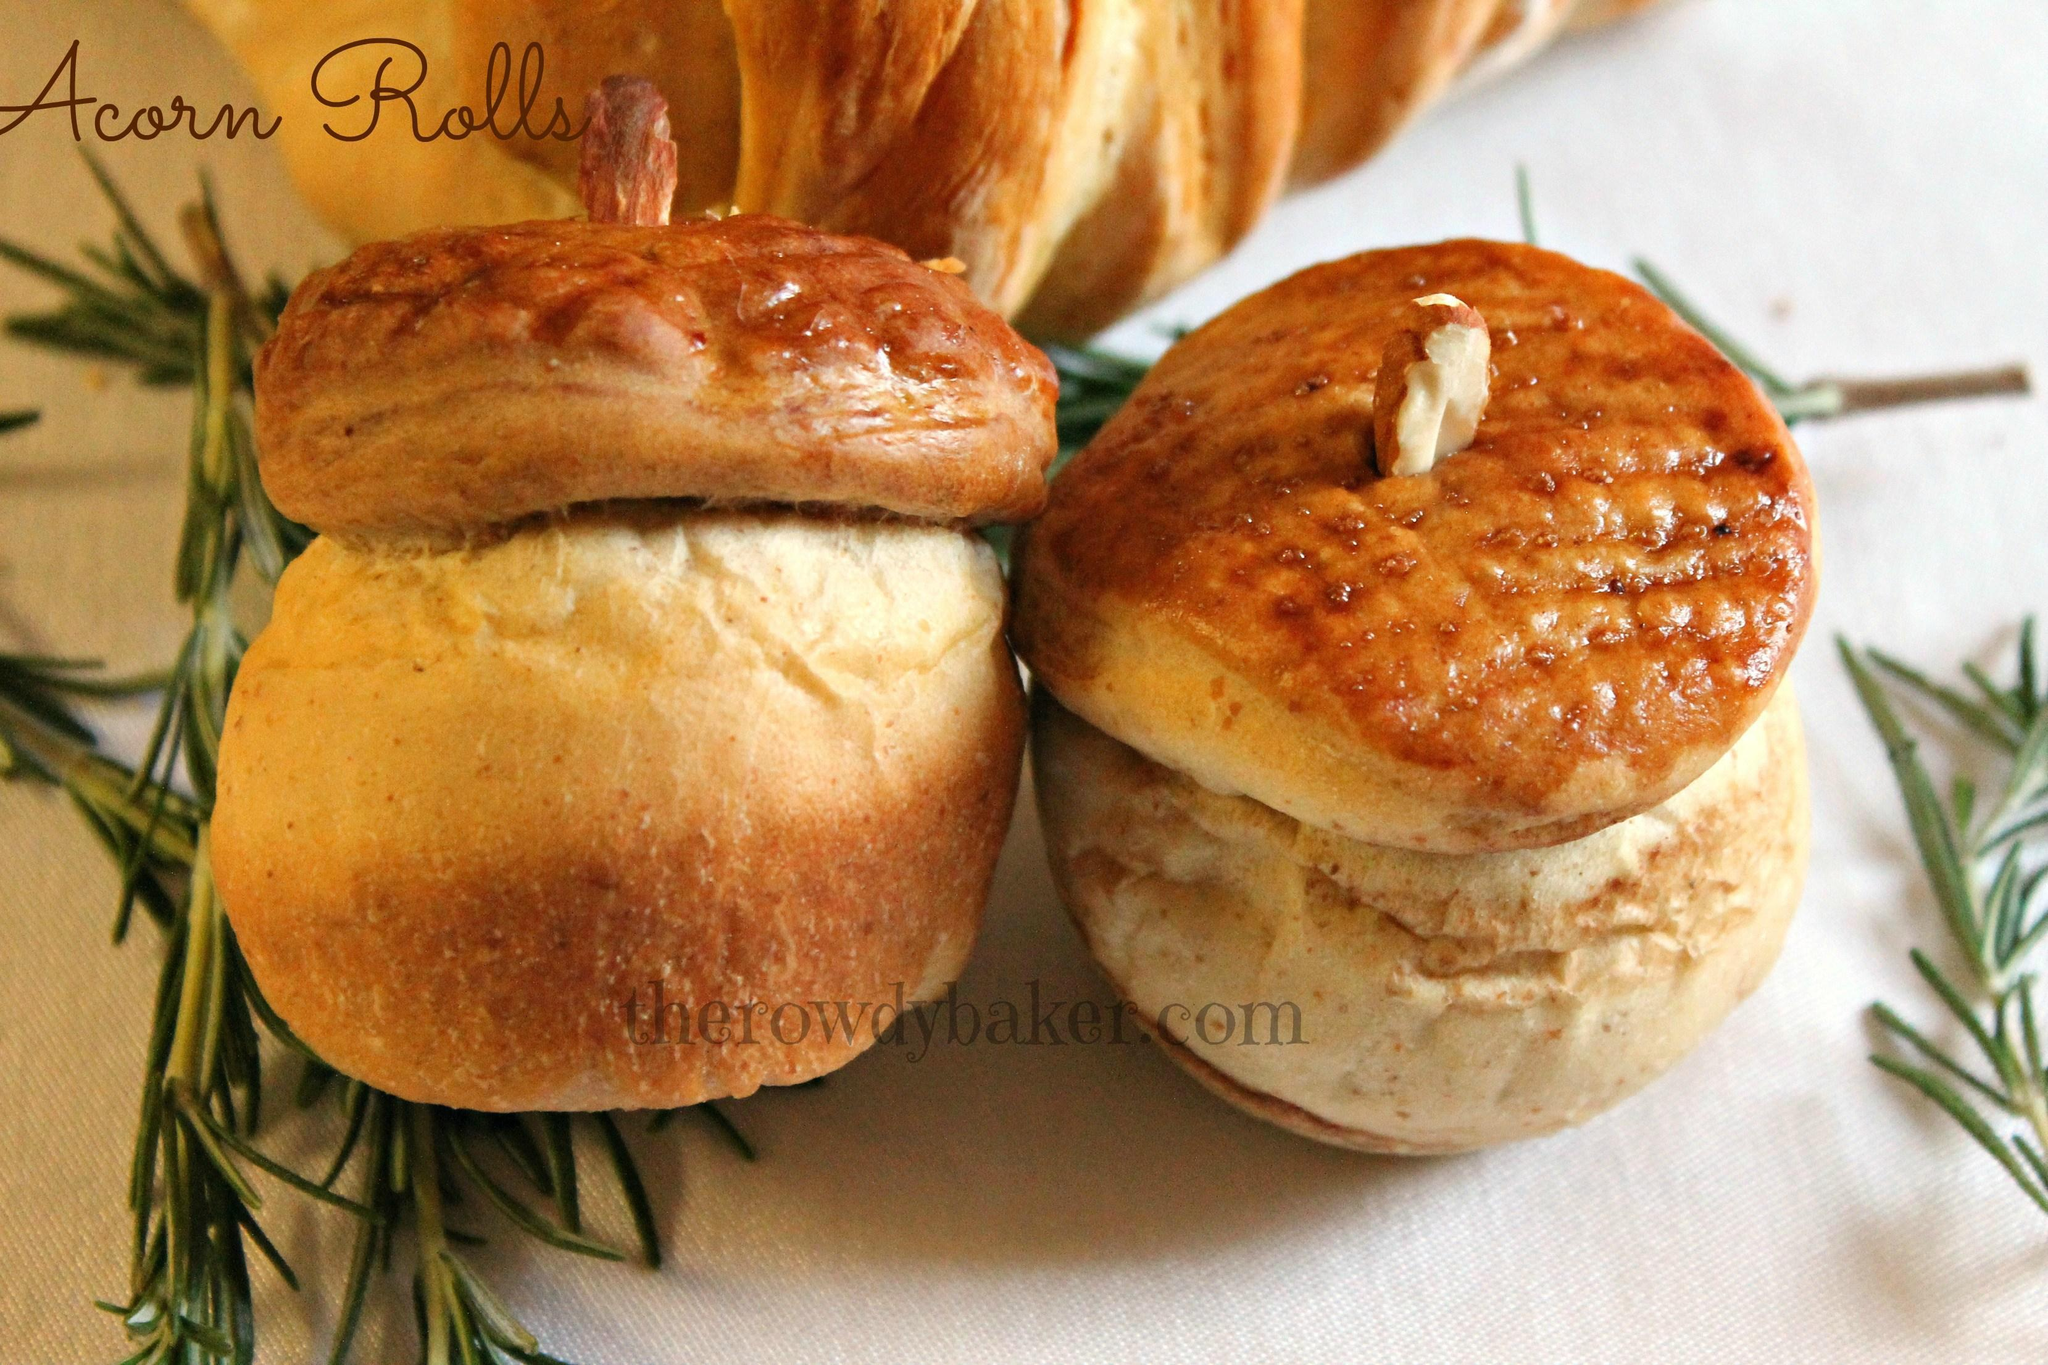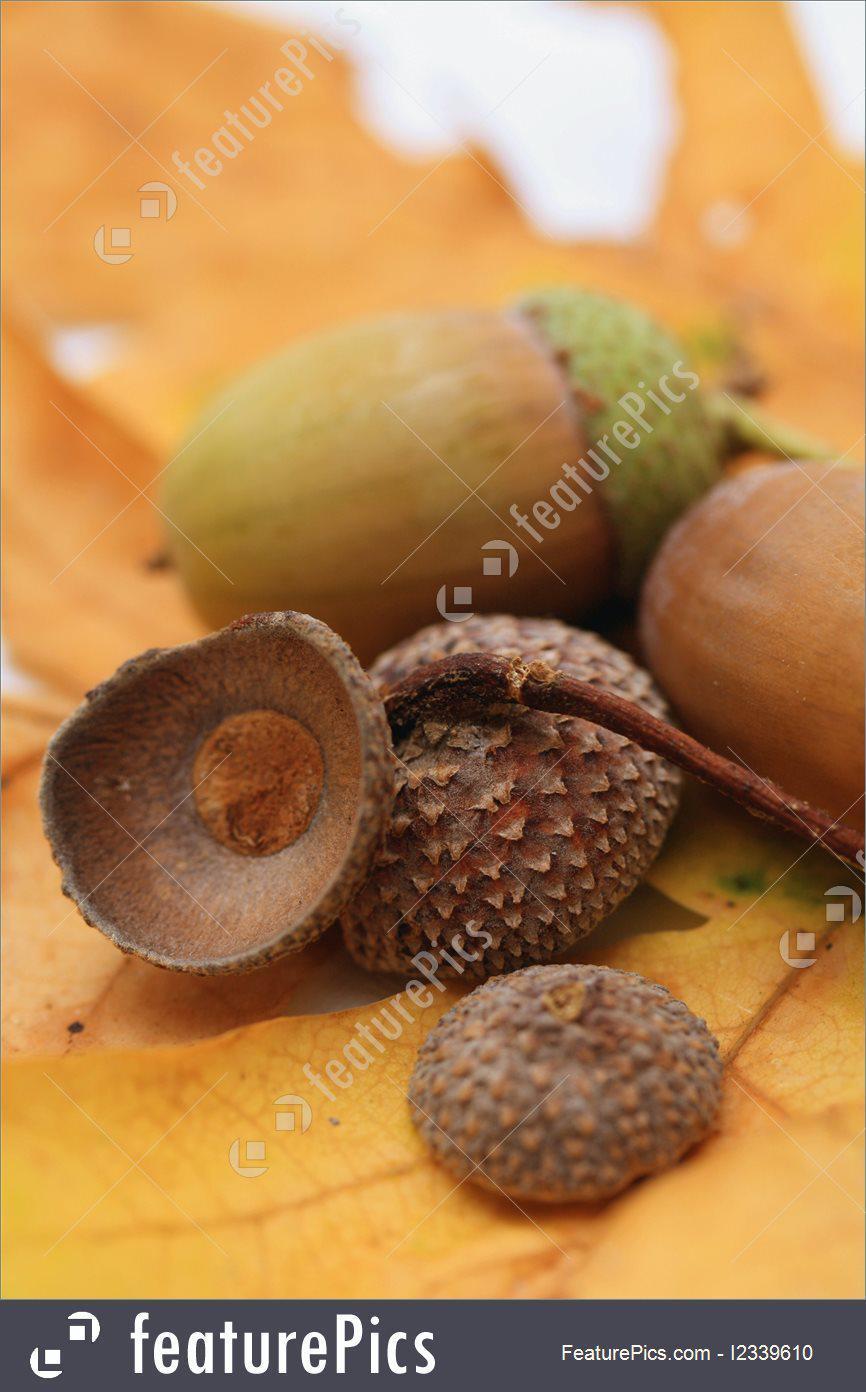The first image is the image on the left, the second image is the image on the right. Considering the images on both sides, is "One of the images is food made to look like acorns." valid? Answer yes or no. Yes. The first image is the image on the left, the second image is the image on the right. Assess this claim about the two images: "The right image shows no more than three acorns on an autumn leaf, and the left image features acorn shapes that aren't really acorns.". Correct or not? Answer yes or no. Yes. 